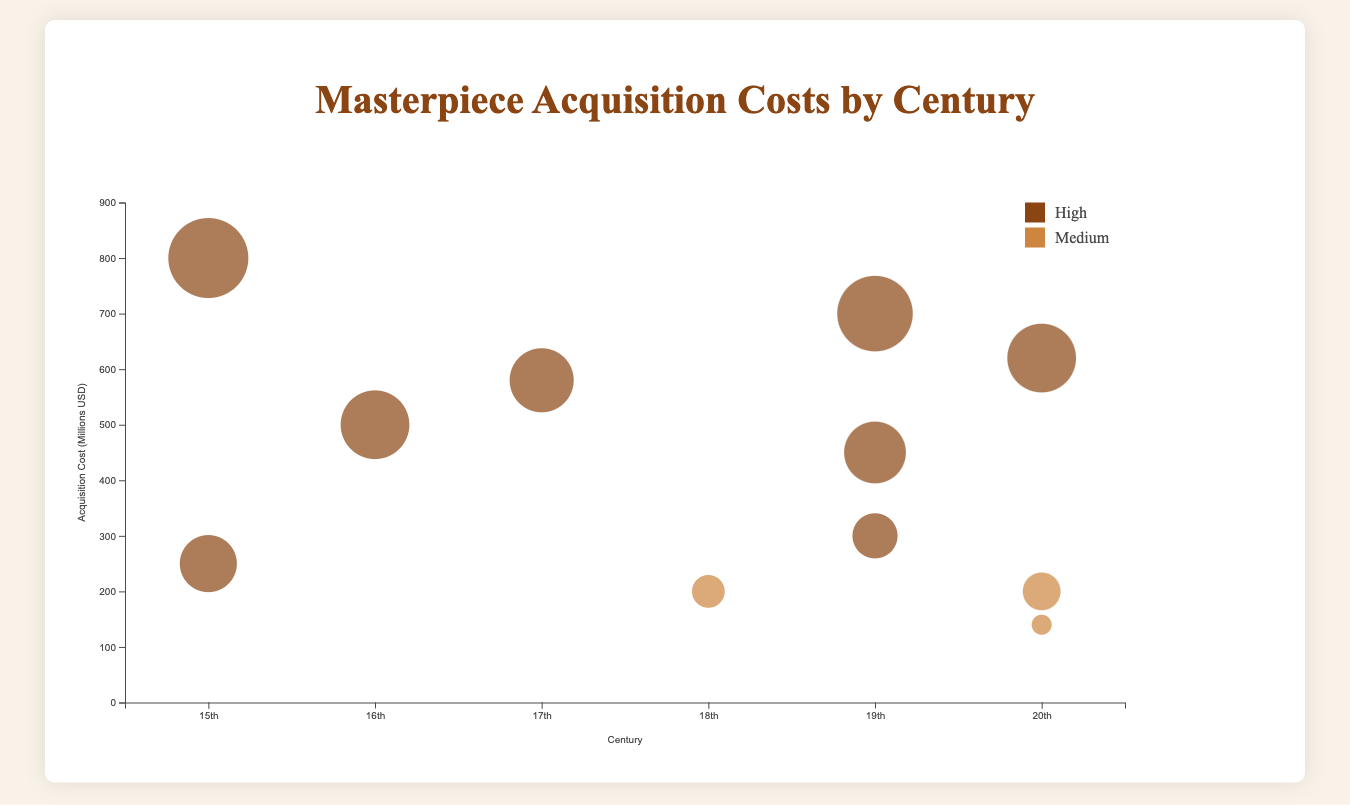What is the title of the chart? The title is located at the top center of the chart and it summarizes the content of the figure.
Answer: Masterpiece Acquisition Costs by Century Which century has the highest acquisition cost? Look for the bubble that is highest on the y-axis. The y-axis represents the acquisition cost.
Answer: 15th century What is the x-axis labeling in this chart? The x-axis labels are directly below the horizontal axis line and represent the different groupings in the data.
Answer: Century How many masterpieces are from the 19th century in the chart? Count the number of bubbles along the x-axis at the 19th-century position.
Answer: 3 What is the acquisition cost of "Nighthawks" by Edward Hopper? Identify the bubble representing "Nighthawks" and note its position on the y-axis.
Answer: $140 million Which artist's masterpiece has the highest rarity score, and what is the cost? Identify the largest bubble, as the radius is proportional to the rarity score, and then check its position on the y-axis.
Answer: Leonardo da Vinci, $800 million Compare the acquisition costs between High and Medium reputation artists in the 20th century. Identify the colors used to differentiate high and medium reputation and note the y-axis positions of the respective bubbles for the 20th century.
Answer: High: $620 million, Medium: $140 million, $200 million Which century has the least variation in acquisition costs? Compare the spread of bubbles along the y-axis for each century. Less variation is indicated by bubbles being closer together vertically.
Answer: 18th century How does the acquisition cost of "Starry Night" compare to "Water Lilies"? Look at the y-axis positions for both bubbles representing these masterpieces.
Answer: Starry Night: $700 million, Water Lilies: $450 million How does the rarity score of "The Birth of Venus" compare to "The Last Judgment"? Look at the radius size of the bubbles representing these masterpieces, as the radius is proportional to the rarity score.
Answer: The Birth of Venus: 85, The Last Judgment: 90 